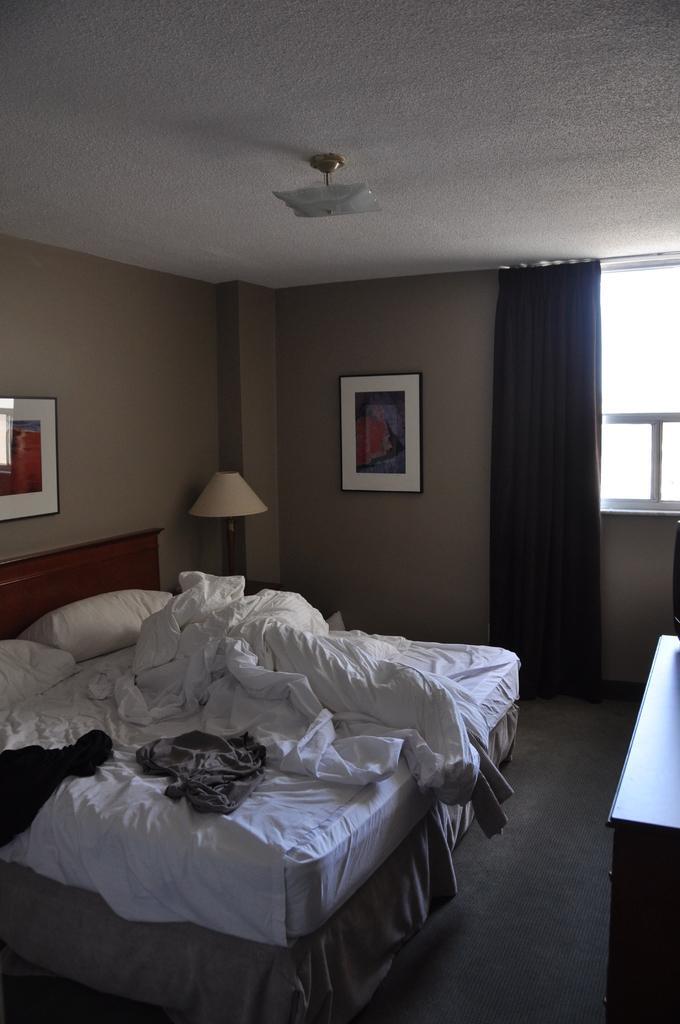Please provide a concise description of this image. It's a Bed in the left and a lamp in this corner and in the right there is a curtain and a window. 